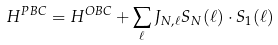<formula> <loc_0><loc_0><loc_500><loc_500>H ^ { P B C } = H ^ { O B C } + \sum _ { \ell } J _ { N , \ell } S _ { N } ( \ell ) \cdot S _ { 1 } ( \ell )</formula> 